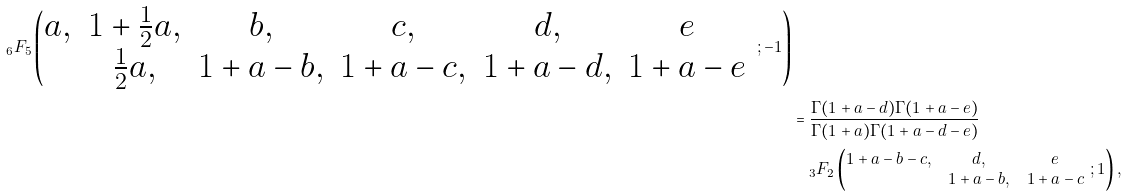<formula> <loc_0><loc_0><loc_500><loc_500>_ { 6 } F _ { 5 } \left ( \begin{matrix} a , & 1 + \frac { 1 } { 2 } a , & b , & c , & d , & e \\ & \frac { 1 } { 2 } a , & 1 + a - b , & 1 + a - c , & 1 + a - d , & 1 + a - e \end{matrix} \ ; - 1 \right ) \\ & = \frac { \Gamma ( 1 + a - d ) \Gamma ( 1 + a - e ) } { \Gamma ( 1 + a ) \Gamma ( 1 + a - d - e ) } \\ & \quad _ { 3 } F _ { 2 } \left ( \begin{matrix} 1 + a - b - c , & d , & e \\ & 1 + a - b , & 1 + a - c \end{matrix} \ ; 1 \right ) ,</formula> 